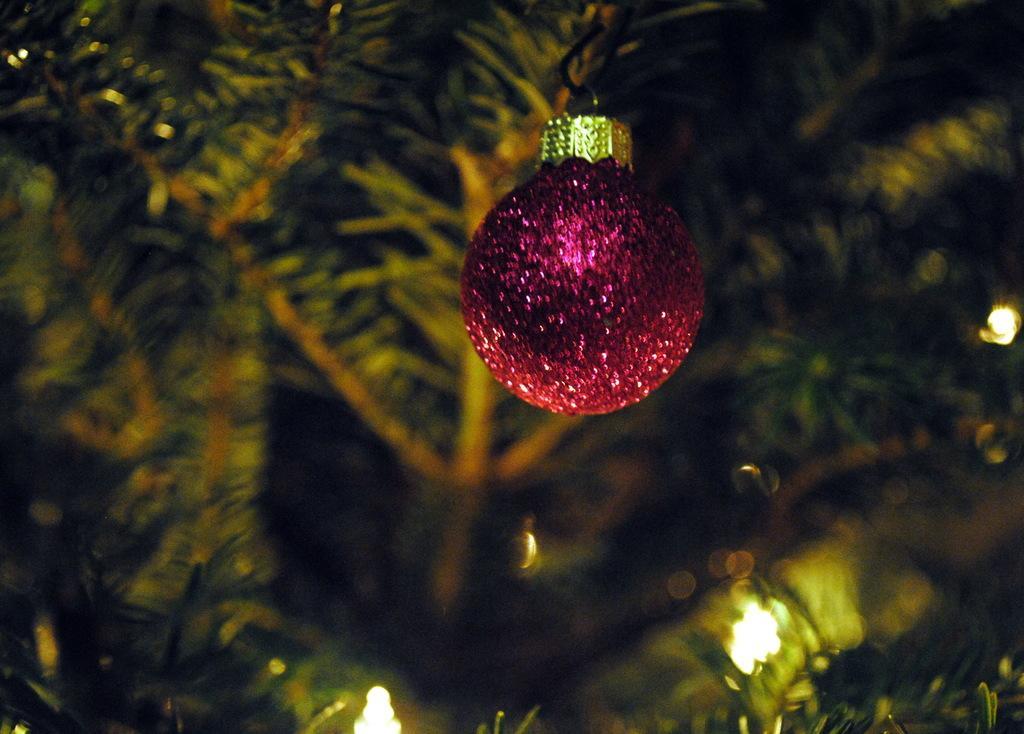Could you give a brief overview of what you see in this image? In the picture I can see a decorative object which is in violet color and there are few trees and lights in the background. 